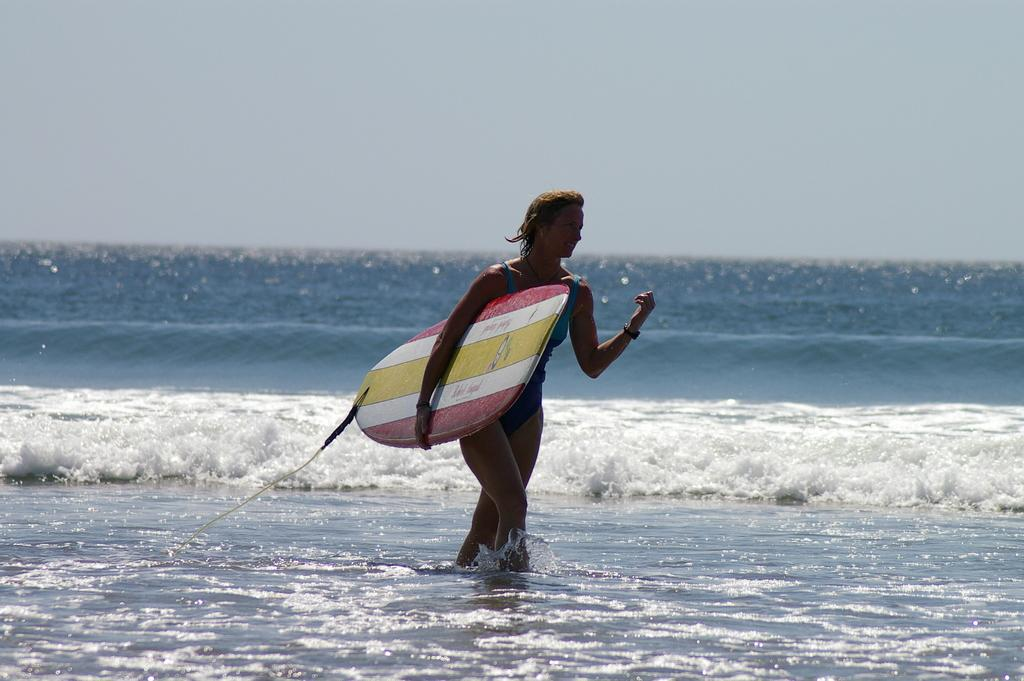Who is the main subject in the image? There is a woman in the image. What is the woman holding in the image? The woman is holding a surfboard. What is the woman doing in the image? The woman is walking in the water. What can be seen in the background of the image? The background of the image is slightly blurred, and the sky is visible. What type of frogs can be seen hopping around the woman in the image? There are no frogs present in the image. What word is written on the surfboard the woman is holding? The image does not provide any information about words written on the surfboard. 